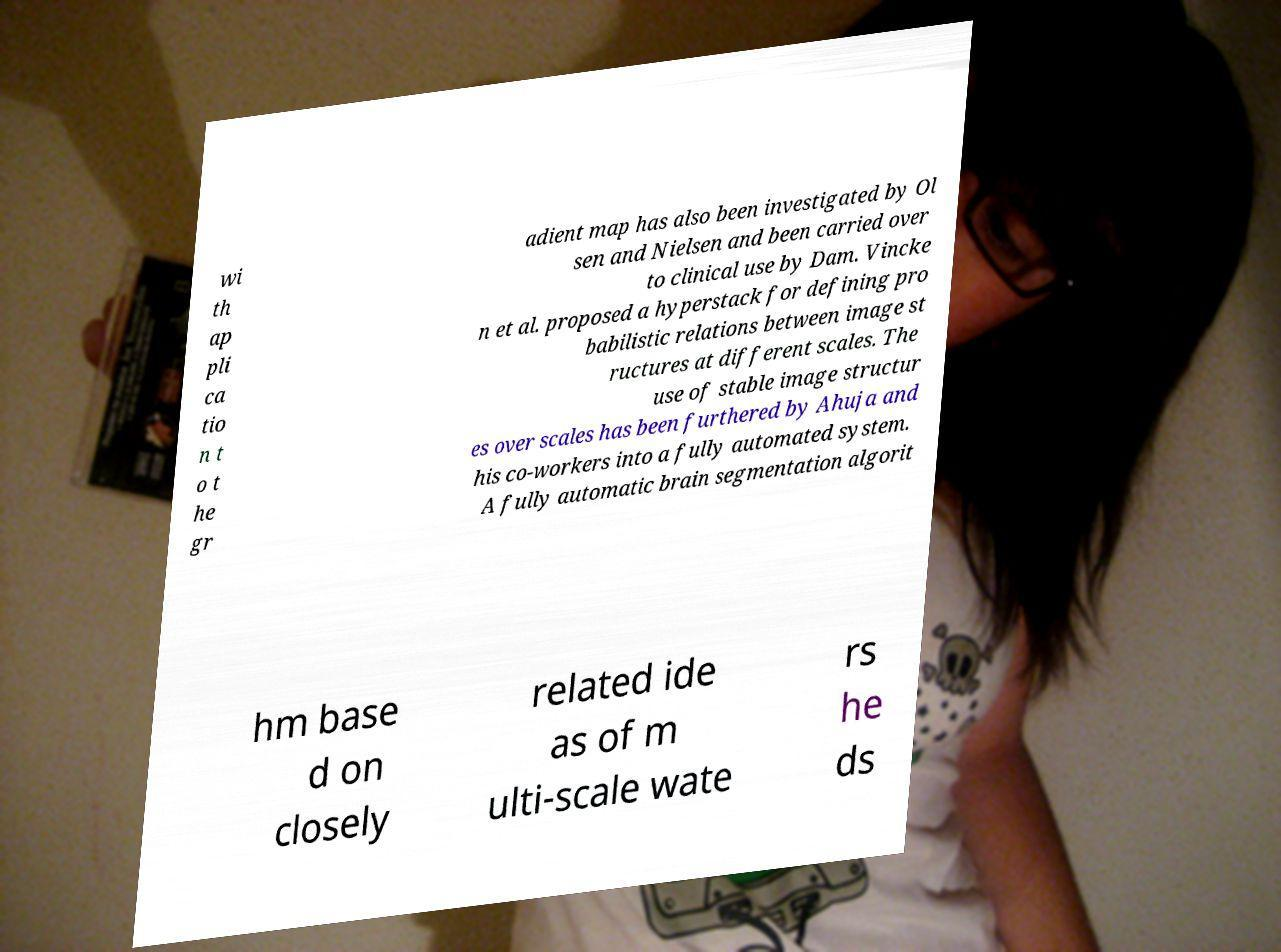Can you read and provide the text displayed in the image?This photo seems to have some interesting text. Can you extract and type it out for me? wi th ap pli ca tio n t o t he gr adient map has also been investigated by Ol sen and Nielsen and been carried over to clinical use by Dam. Vincke n et al. proposed a hyperstack for defining pro babilistic relations between image st ructures at different scales. The use of stable image structur es over scales has been furthered by Ahuja and his co-workers into a fully automated system. A fully automatic brain segmentation algorit hm base d on closely related ide as of m ulti-scale wate rs he ds 